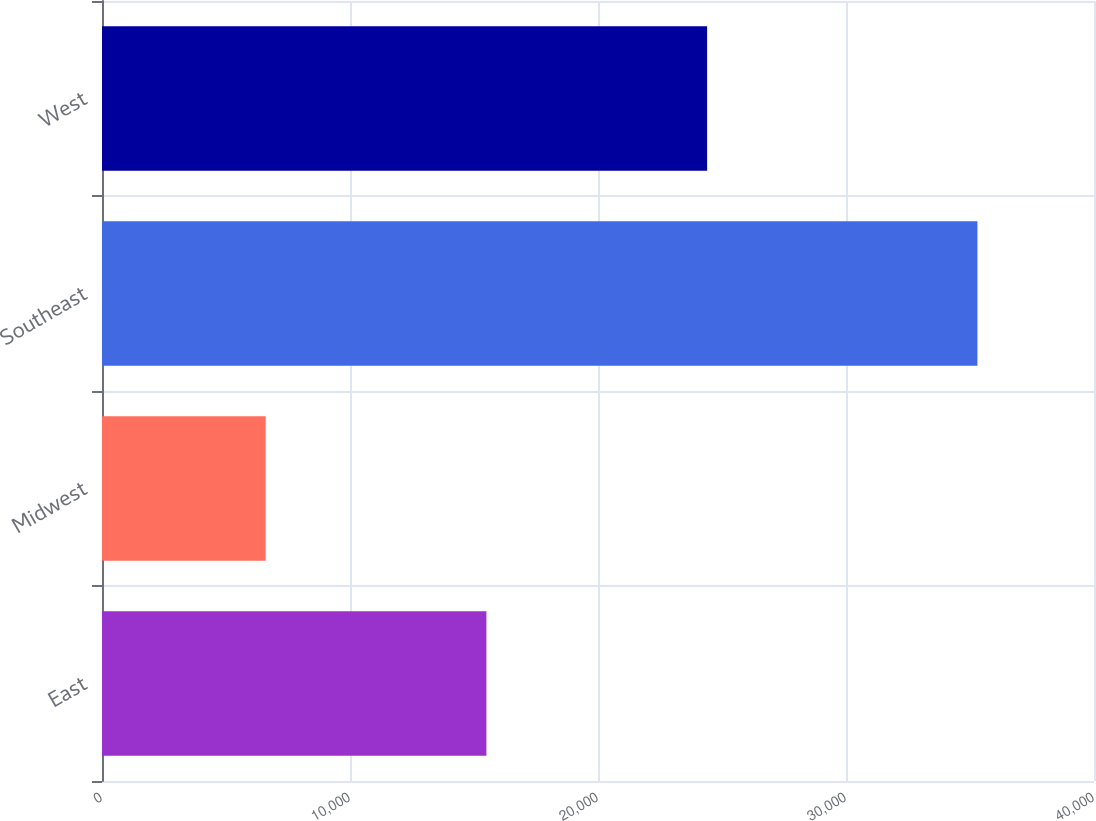Convert chart to OTSL. <chart><loc_0><loc_0><loc_500><loc_500><bar_chart><fcel>East<fcel>Midwest<fcel>Southeast<fcel>West<nl><fcel>15500<fcel>6600<fcel>35300<fcel>24400<nl></chart> 